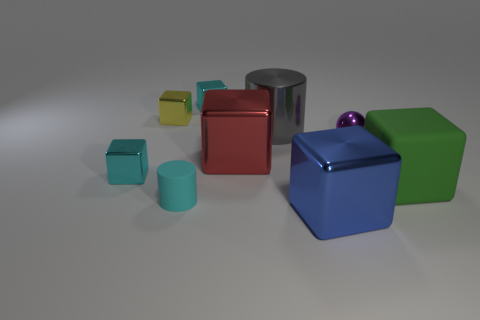What material is the red object that is the same shape as the large green matte thing?
Keep it short and to the point. Metal. Is the number of purple metal objects that are to the right of the large rubber thing less than the number of large yellow metallic objects?
Your answer should be compact. No. How many cyan cubes are to the left of the green matte thing?
Your answer should be compact. 2. Does the cyan object behind the sphere have the same shape as the red metallic object on the right side of the cyan matte thing?
Keep it short and to the point. Yes. There is a big metallic thing that is in front of the small purple sphere and behind the big blue metal object; what is its shape?
Ensure brevity in your answer.  Cube. What size is the red cube that is made of the same material as the tiny yellow cube?
Your response must be concise. Large. Are there fewer cyan shiny blocks than shiny objects?
Your answer should be very brief. Yes. There is a big block right of the block that is in front of the large green thing in front of the sphere; what is its material?
Make the answer very short. Rubber. Is the material of the cube to the right of the purple metal sphere the same as the large red cube that is to the left of the large blue object?
Provide a short and direct response. No. There is a object that is behind the big green thing and in front of the big red shiny thing; what size is it?
Offer a terse response. Small. 